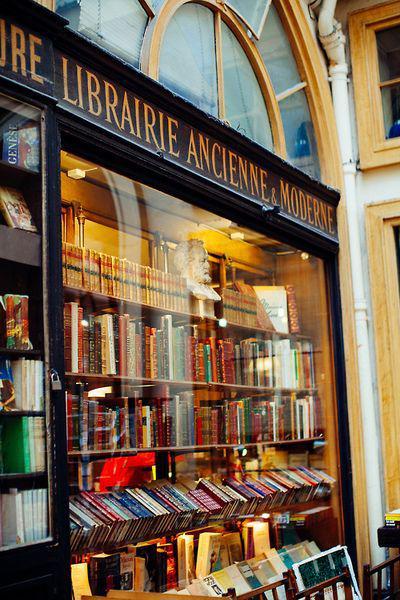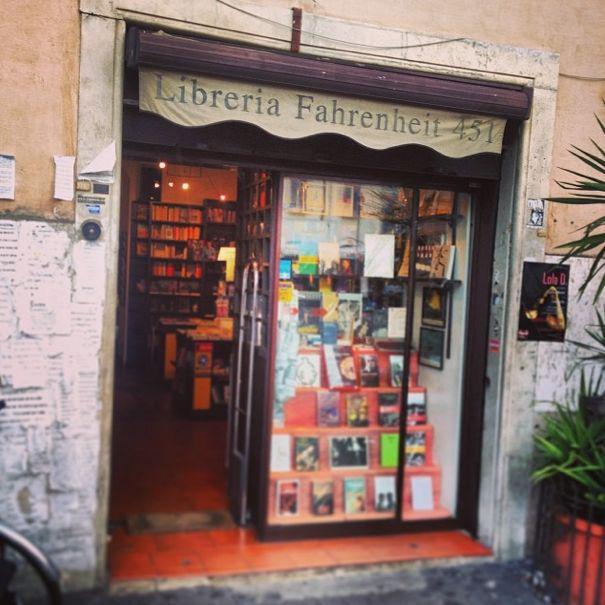The first image is the image on the left, the second image is the image on the right. Analyze the images presented: Is the assertion "In one image a bookstore with its entrance located between two large window areas has at least one advertising placard on the sidewalk in front." valid? Answer yes or no. No. 